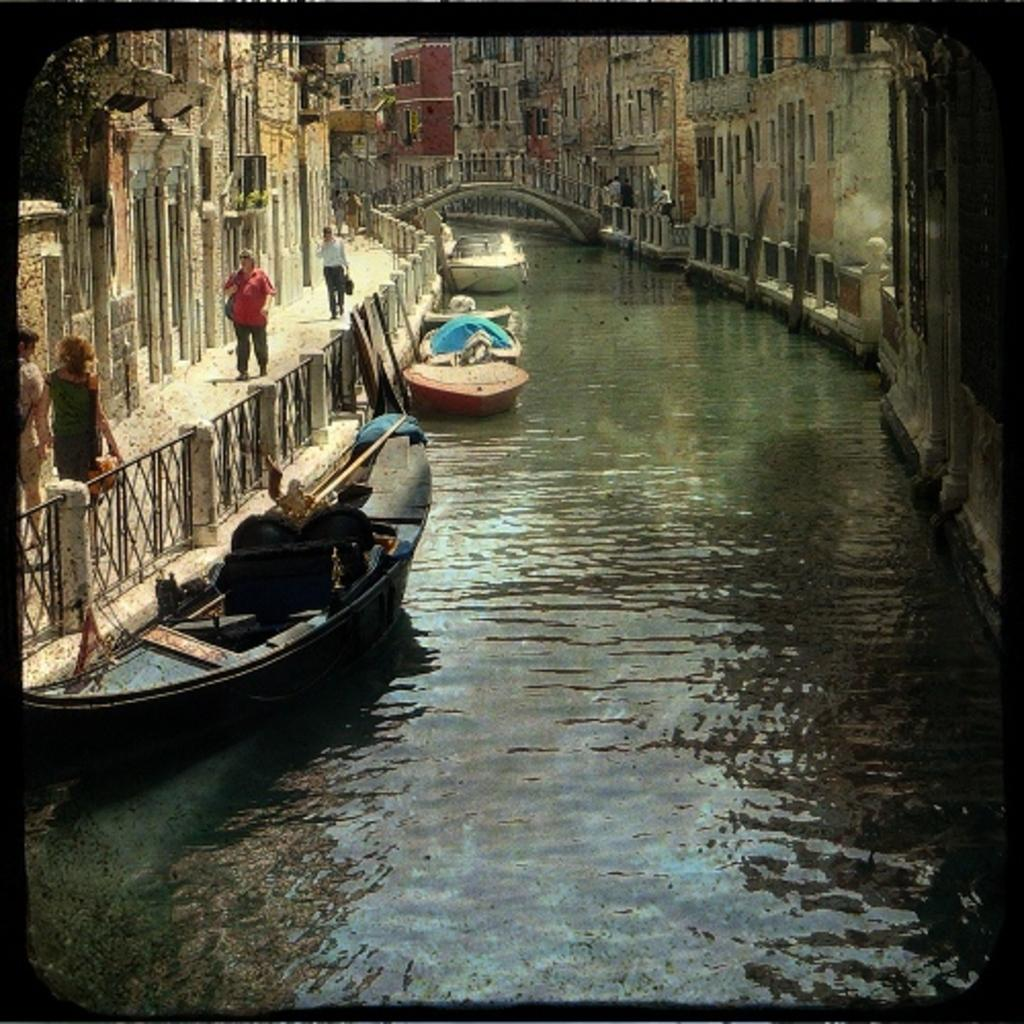What type of vehicles can be seen in the water in the image? There are boats in the water in the image. Can you describe the people visible in the image? There are persons visible in the image. What structures are located on either side of the water? There are buildings on either side of the water. What architectural feature is visible in the background of the image? There is a bridge above the water in the background. Where is the crate located in the image? There is no crate present in the image. What type of brake system is used on the boats in the image? The image does not provide information about the boats' brake systems. Can you tell me how many sinks are visible in the image? There are no sinks visible in the image. 